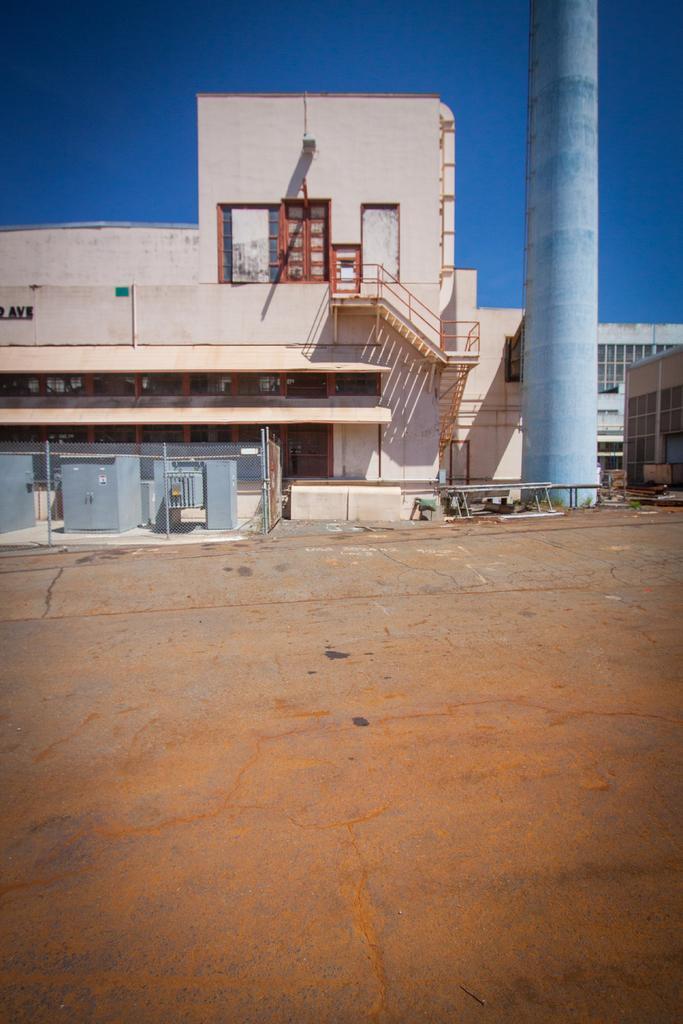How would you summarize this image in a sentence or two? In this picture we can see a ground, buildings, tower and some objects and we can see sky in the background. 